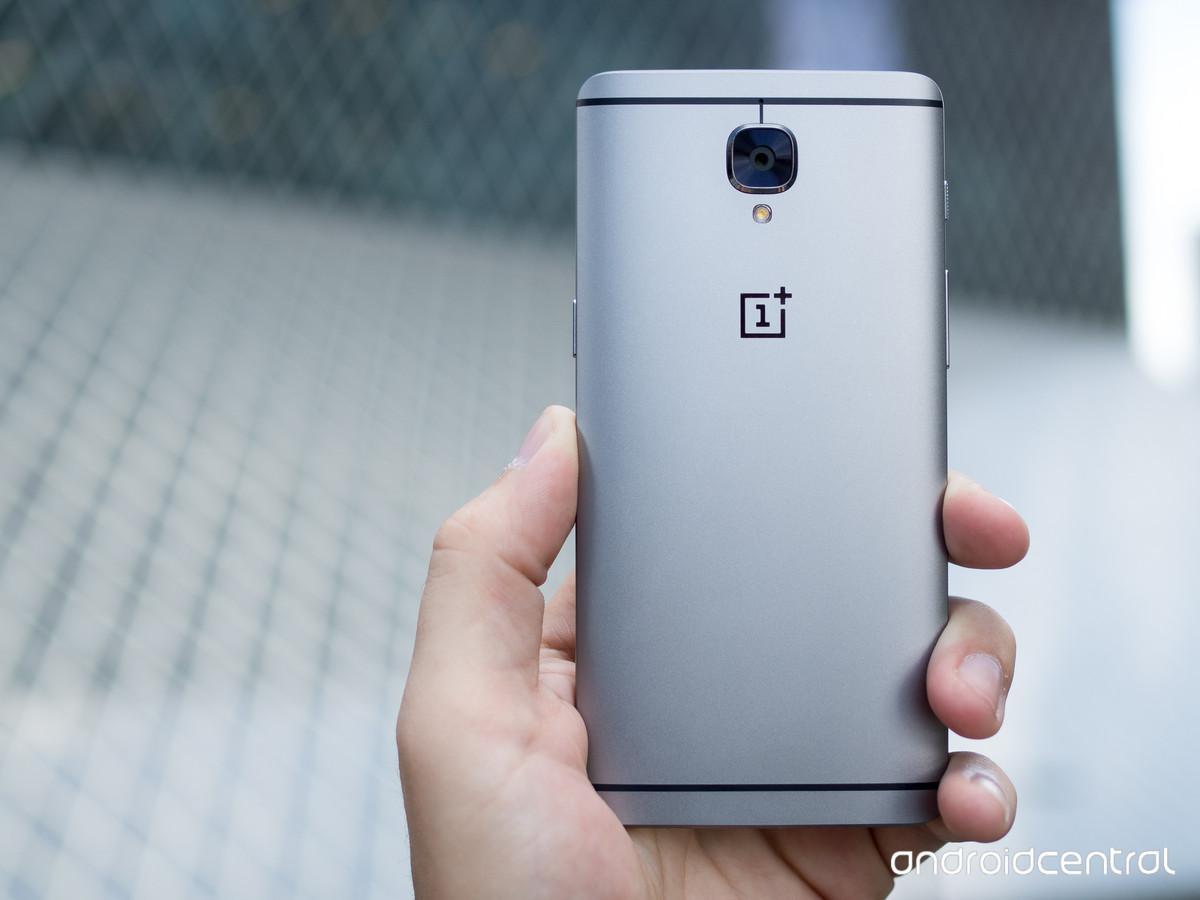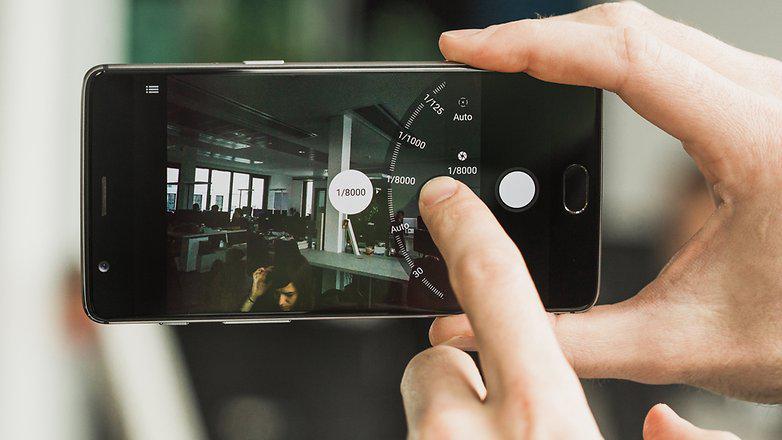The first image is the image on the left, the second image is the image on the right. Assess this claim about the two images: "There are two phones and one hand.". Correct or not? Answer yes or no. No. The first image is the image on the left, the second image is the image on the right. Assess this claim about the two images: "There are three hands.". Correct or not? Answer yes or no. Yes. 